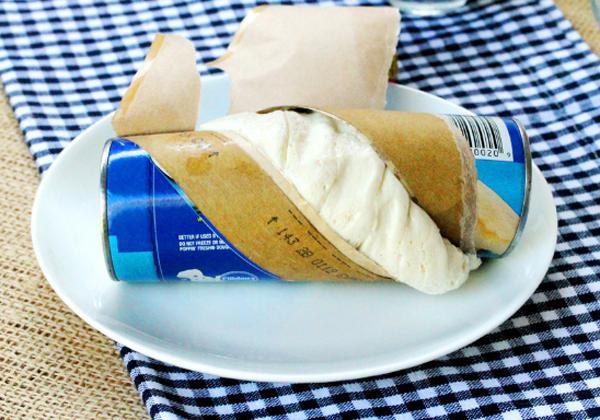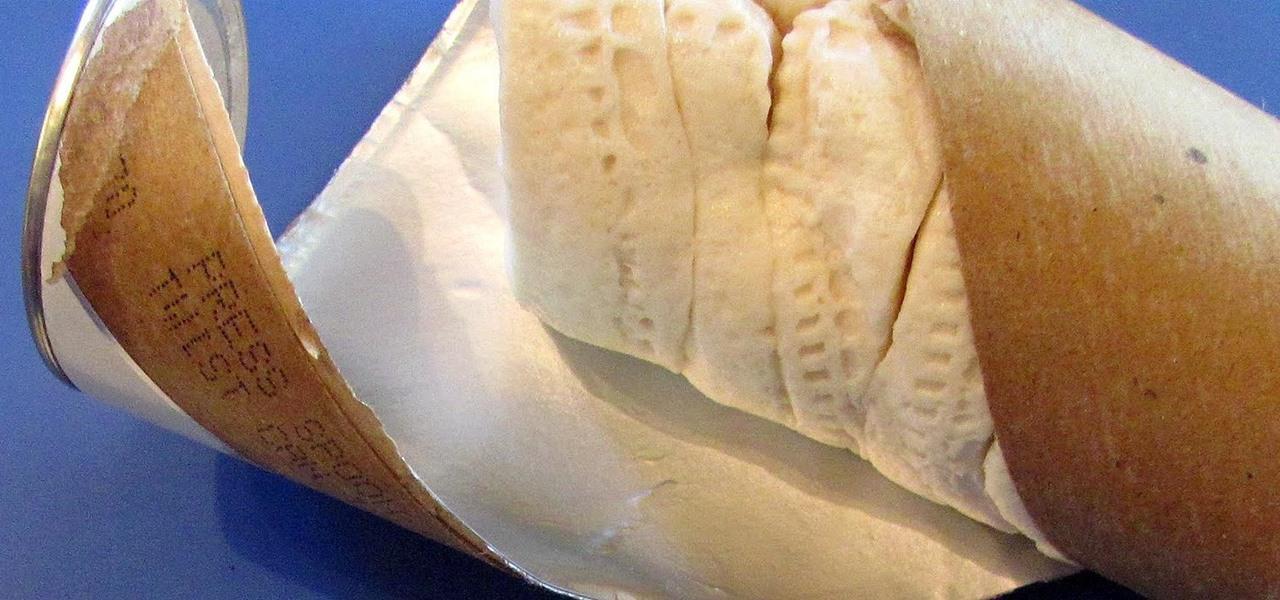The first image is the image on the left, the second image is the image on the right. For the images shown, is this caption "The dough in at least one image is still in a round biscuit can shape." true? Answer yes or no. Yes. The first image is the image on the left, the second image is the image on the right. Given the left and right images, does the statement "Some dough is shaped like a cylinder." hold true? Answer yes or no. Yes. 